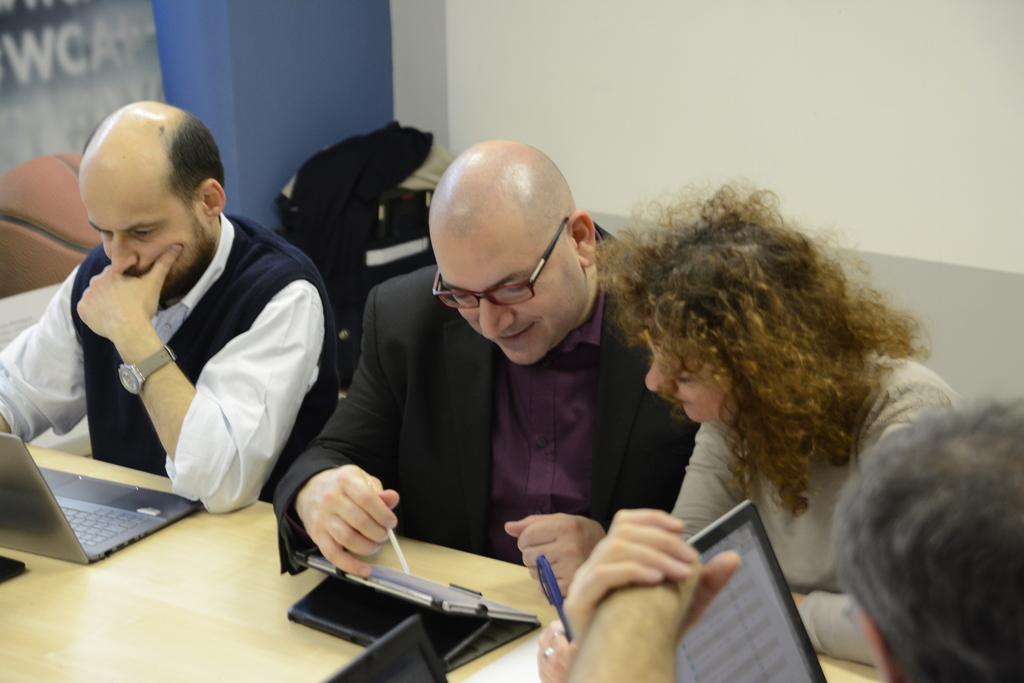Can you describe this image briefly? In this image we can see two men and one woman sitting in front of a table and on the table we can see a notepad and also a laptop. There is also another person on the right. In the background we can see a plain wall. 